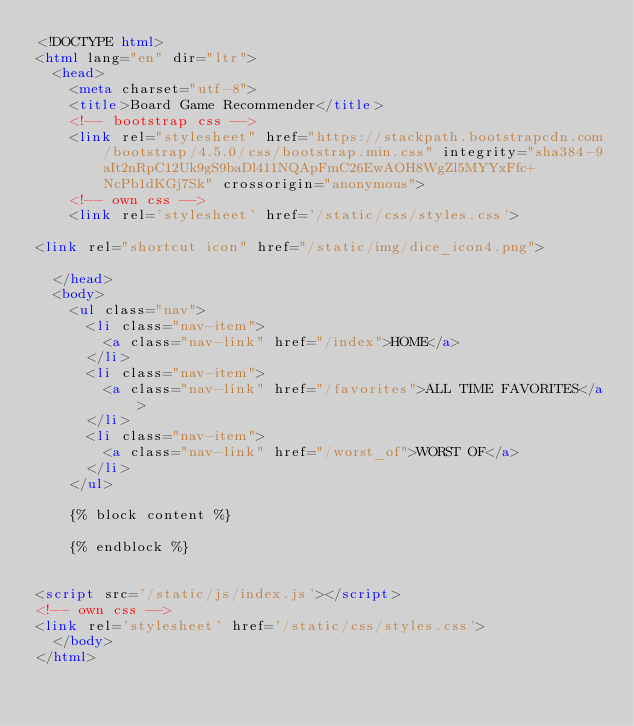<code> <loc_0><loc_0><loc_500><loc_500><_HTML_><!DOCTYPE html>
<html lang="en" dir="ltr">
  <head>
    <meta charset="utf-8">
    <title>Board Game Recommender</title>
    <!-- bootstrap css -->
    <link rel="stylesheet" href="https://stackpath.bootstrapcdn.com/bootstrap/4.5.0/css/bootstrap.min.css" integrity="sha384-9aIt2nRpC12Uk9gS9baDl411NQApFmC26EwAOH8WgZl5MYYxFfc+NcPb1dKGj7Sk" crossorigin="anonymous">
    <!-- own css -->
    <link rel='stylesheet' href='/static/css/styles.css'>

<link rel="shortcut icon" href="/static/img/dice_icon4.png">

  </head>
  <body>
    <ul class="nav">
      <li class="nav-item">
        <a class="nav-link" href="/index">HOME</a>
      </li>
      <li class="nav-item">
        <a class="nav-link" href="/favorites">ALL TIME FAVORITES</a>
      </li>
      <li class="nav-item">
        <a class="nav-link" href="/worst_of">WORST OF</a>
      </li>
    </ul>

    {% block content %}

    {% endblock %}


<script src='/static/js/index.js'></script>
<!-- own css -->
<link rel='stylesheet' href='/static/css/styles.css'>
  </body>
</html>
</code> 